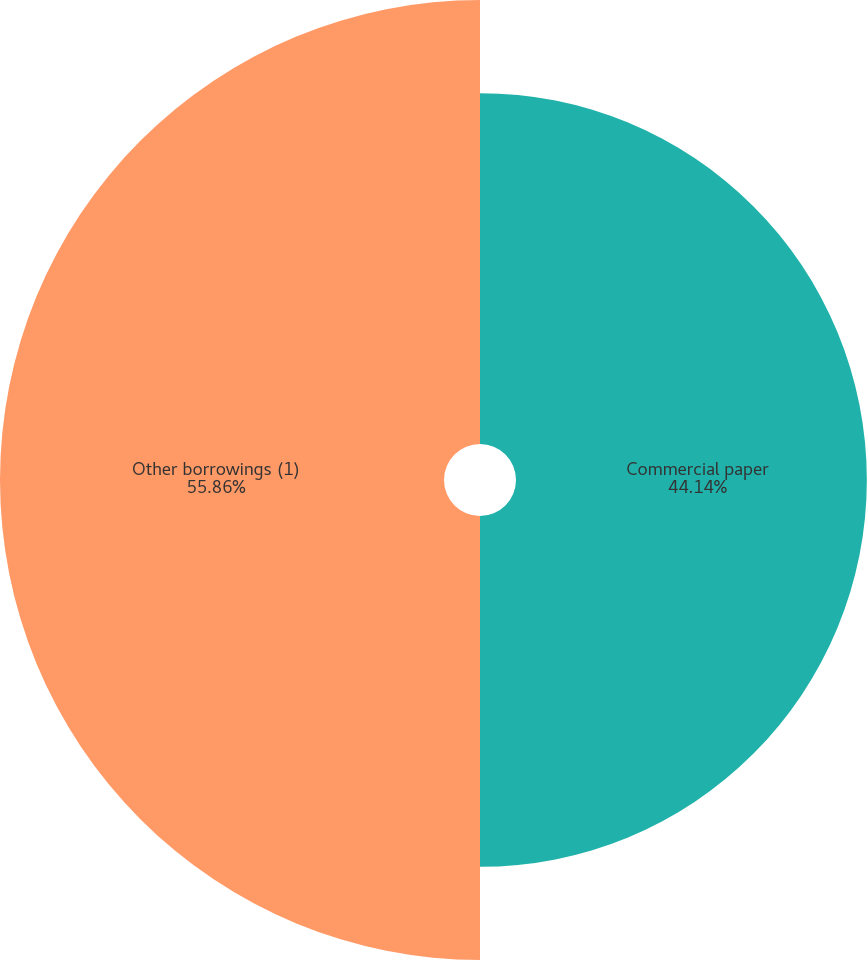Convert chart. <chart><loc_0><loc_0><loc_500><loc_500><pie_chart><fcel>Commercial paper<fcel>Other borrowings (1)<nl><fcel>44.14%<fcel>55.86%<nl></chart> 